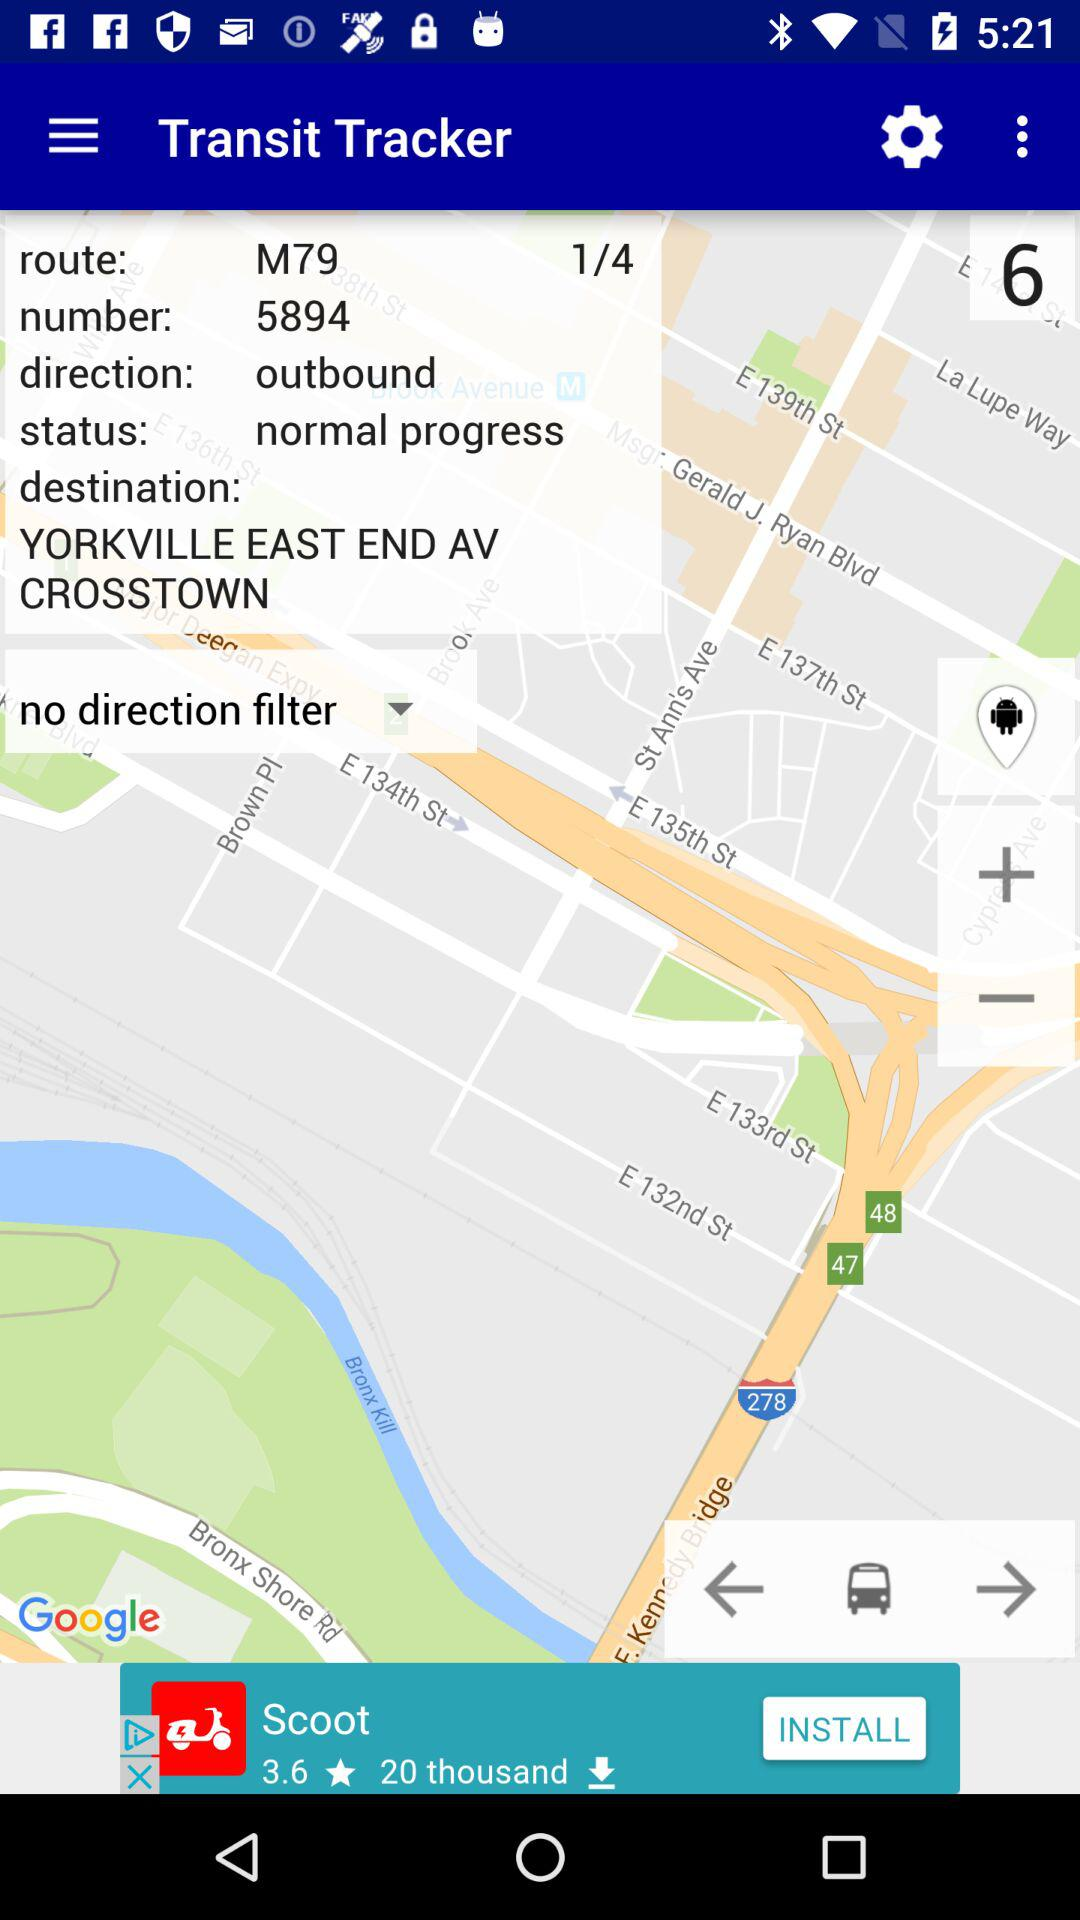What is the status of the tracker? The status is "normal progress". 